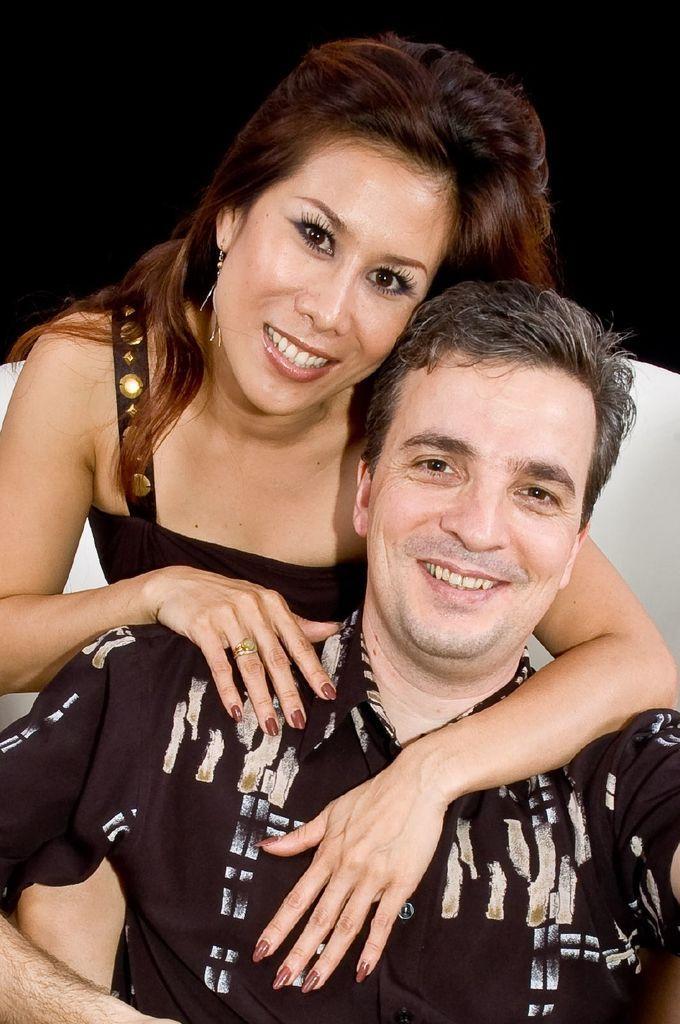How would you summarize this image in a sentence or two? In the middle of the image two persons are sitting and smiling. 